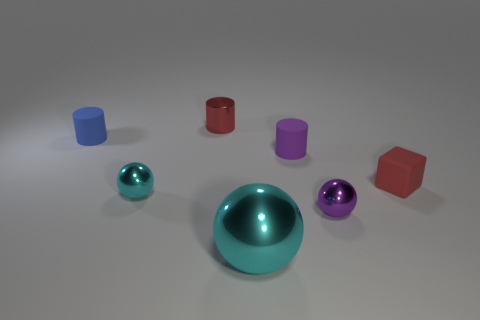Can you describe the different materials visible in the image? Certainly, the image shows objects with varying materials. There's a red metal cylinder with a reflective surface, indicating it's likely a hard, smooth material. The blue and purple objects seem to be made of rubber due to their matte finish, which suggests a softer, more flexible material. The spheres look glossy, perhaps made from a polished stone or a type of plastic. Which object seems out of place based on its size? Relative to the other items, the large teal sphere in the middle stands out due to its substantially larger size. It creates a visually compelling central point that might be suggestive of its importance or uniqueness among the other objects. 